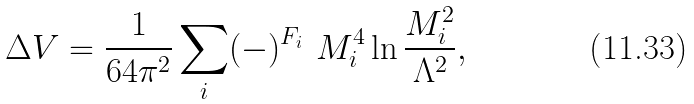<formula> <loc_0><loc_0><loc_500><loc_500>\Delta V = \frac { 1 } { 6 4 \pi ^ { 2 } } \sum _ { i } ( - ) ^ { F _ { i } } \ M _ { i } ^ { 4 } \ln \frac { M _ { i } ^ { 2 } } { \Lambda ^ { 2 } } ,</formula> 